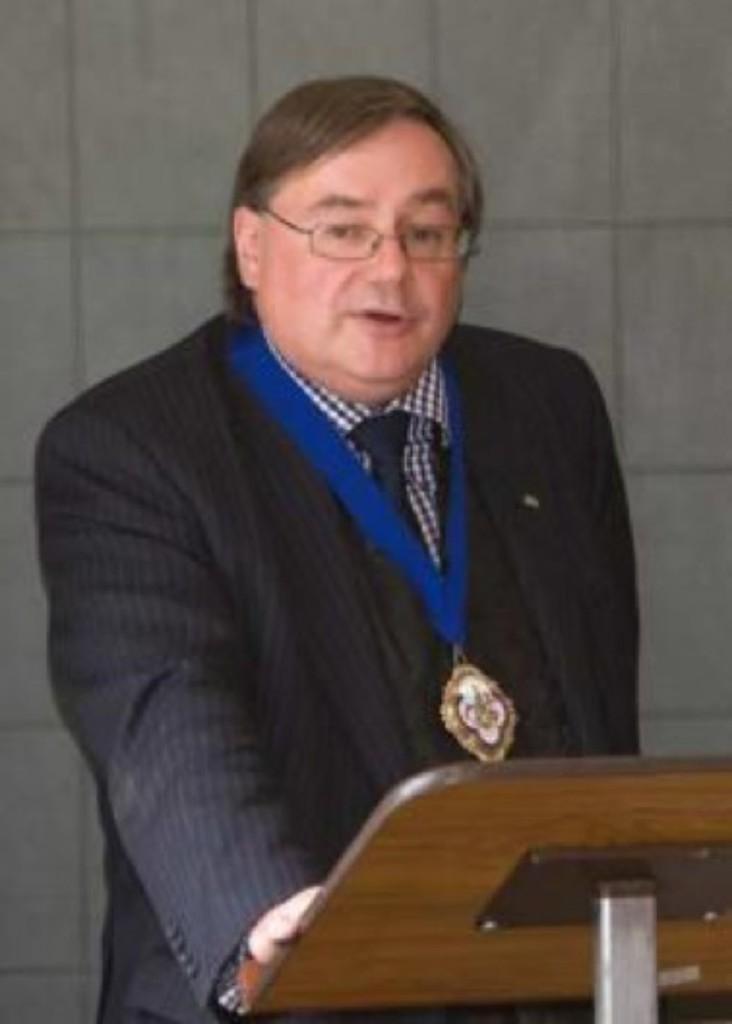Please provide a concise description of this image. This person standing and wear medal,glasses and talking,in front of this person we can see table. On the background we can see wall. 